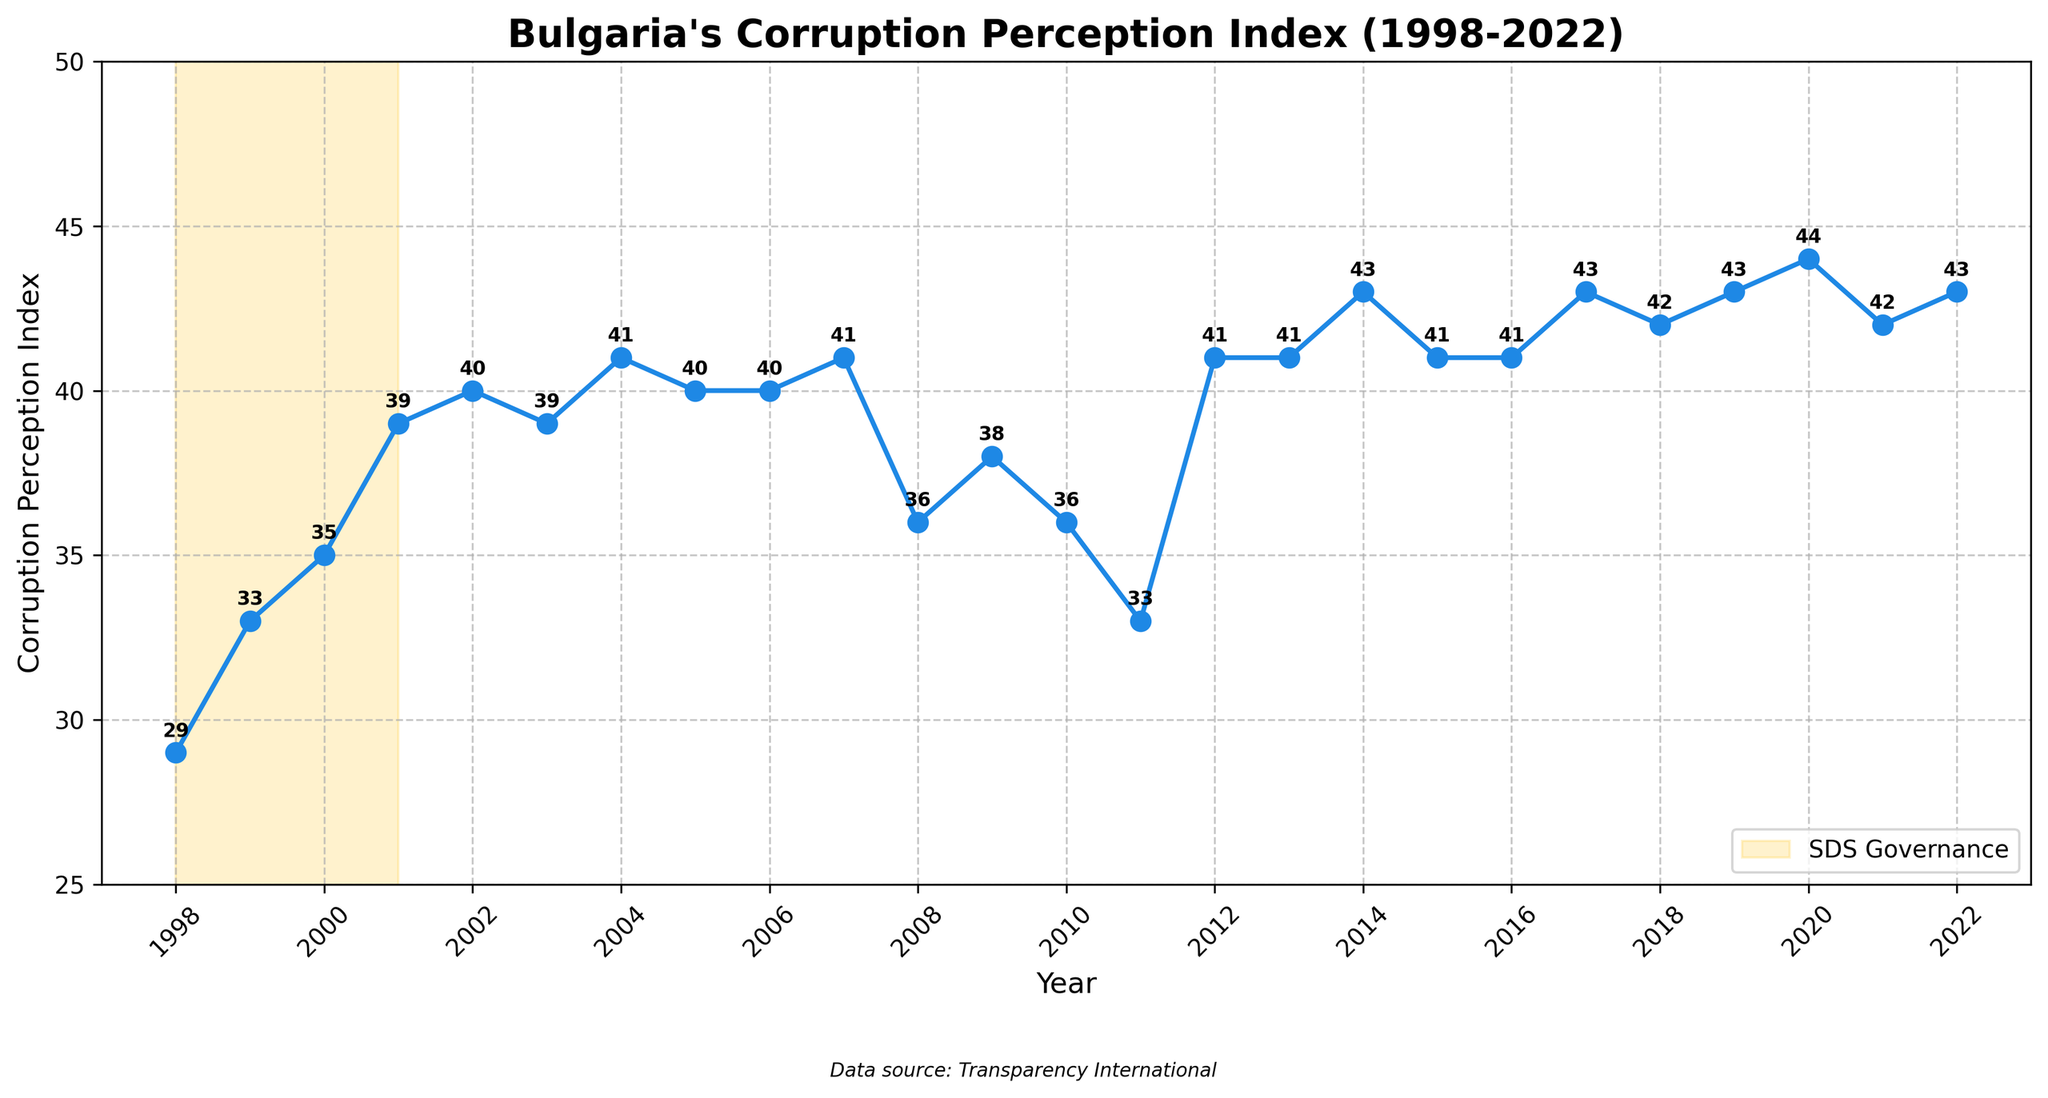What year had the highest Corruption Perception Index (CPI) score? Look at the y-axis to identify the highest CPI score and find the corresponding year on the x-axis. The highest score is 44 in 2020.
Answer: 2020 Which governments oversaw an increase in CPI scores from the previous year? Identify the years where the CPI score increased compared to the previous year and check the government in charge during those years. The years are 1999, 2000, 2001 (all Ivan Kostov, SDS), 2014, and 2020 (Boyko Borisov, GERB).
Answer: Ivan Kostov (SDS) and Boyko Borisov (GERB) How did the CPI score change during the periods of SDS governance? During SDS governance (1998-2001), check the CPI score points. The CPI rose from 29 in 1998 to 39 in 2001.
Answer: Increased from 29 to 39 What is the difference in CPI scores between the highest and lowest points? Identify the highest (44 in 2020) and lowest (29 in 1998) CPI scores. Calculate the difference as 44 - 29.
Answer: 15 Which government saw the largest decrease in CPI during their term? Identify the years with decreasing CPI scores within the same government's term. Compare the total decreases and find the maximum. Sergei Stanishev (2008: 41 to 36) had the largest single drop.
Answer: Sergei Stanishev (BSP) During which years did the CPI score remain the same compared to the previous year? Check for consecutive years with identical CPI scores. This occurred in 2005-2006 and 2012-2013.
Answer: 2005-2006 and 2012-2013 Which year experienced the biggest single-year CPI score drop? Compare yearly decreases and identify the year with the maximum single-year drop. 2011-2012 had a drop from 41 to 33.
Answer: 2011 How did the CPI score change during Boyko Borisov's terms? Identify Boyko Borisov's terms (2009-2012, 2014-2020) and look at the CPI scores. It fluctuated initially but rose from 38 in 2009 to 44 in 2020.
Answer: Fluctuated but increased overall What is the average CPI score during SDS governance? Sum the CPI scores of the SDS governance years (29, 33, 35, 39) and divide by the number of years (4). The average is (29 + 33 + 35 + 39) / 4 = 34.
Answer: 34 How does Stefan Yanev's caretaker government CPI score compare to the previous year? Check the CPI score for 2021 (42) and compare it to 2020 (44). The score decreased by 2 points.
Answer: Decreased by 2 points 